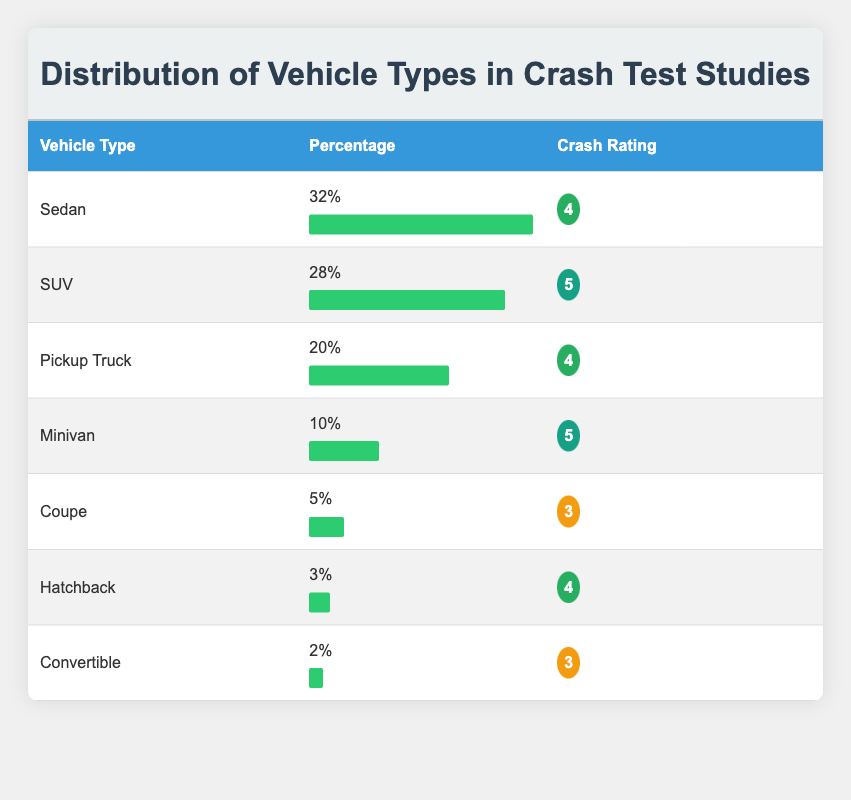What percentage of vehicles tested are SUVs? The table shows that SUVs have a percentage value listed next to them, which is 28%.
Answer: 28% Which vehicle type has the highest crash rating? The crash ratings are listed alongside each vehicle type. The SUV has the highest crash rating of 5.
Answer: SUV What is the combined percentage of Pickup Trucks and Minivans? To find the combined percentage, we add the values for Pickup Trucks (20%) and Minivans (10%). Therefore, 20% + 10% = 30%.
Answer: 30% Are there any vehicle types that have a crash rating of 3? The table lists the Coupe and Convertible both with a crash rating of 3, thus confirming that there are vehicle types with that rating.
Answer: Yes What is the average crash rating of all vehicle types in the study? To find the average crash rating, we first add all the crash ratings: (4 + 5 + 4 + 5 + 3 + 4 + 3) = 28. Then, we divide by the number of vehicle types (7). Therefore, 28 / 7 = 4.
Answer: 4 Which vehicle type has the lowest representation in the crash tests? The table details the percentage of vehicle types, and the Convertible has the lowest representation at 2%.
Answer: Convertible Is the percentage of Hatchbacks greater than that of Coupes? The Hatchback has a percentage of 3%, while the Coupe has a percentage of 5%. As 3% is less than 5%, it confirms Hatchbacks are not greater.
Answer: No How does the percentage of Sedans compare to the total of SUVs and Pickup Trucks? The percentage of Sedans is 32%. The total percentage of SUVs (28%) and Pickup Trucks (20%) is 48%. Comparing these values, 32% is less than 48%.
Answer: Less What is the difference in crash ratings between Minivans and Coupes? Minivans have a crash rating of 5, and Coupes have a crash rating of 3. The difference is calculated as 5 - 3 = 2.
Answer: 2 